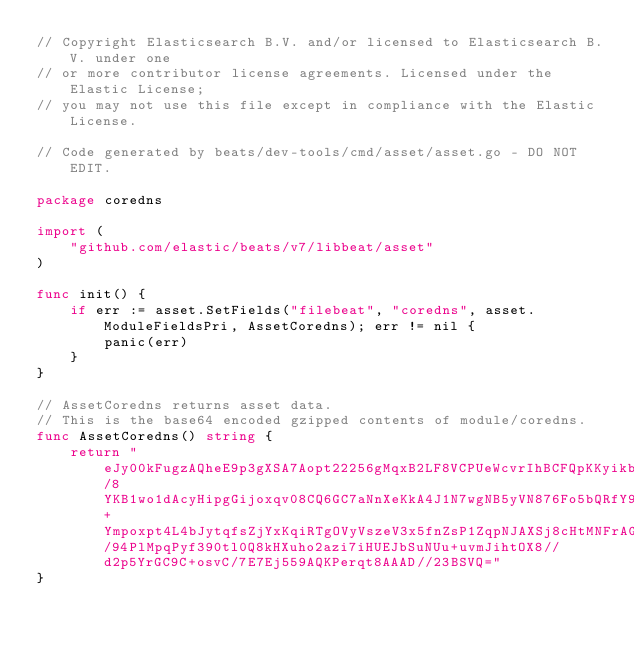<code> <loc_0><loc_0><loc_500><loc_500><_Go_>// Copyright Elasticsearch B.V. and/or licensed to Elasticsearch B.V. under one
// or more contributor license agreements. Licensed under the Elastic License;
// you may not use this file except in compliance with the Elastic License.

// Code generated by beats/dev-tools/cmd/asset/asset.go - DO NOT EDIT.

package coredns

import (
	"github.com/elastic/beats/v7/libbeat/asset"
)

func init() {
	if err := asset.SetFields("filebeat", "coredns", asset.ModuleFieldsPri, AssetCoredns); err != nil {
		panic(err)
	}
}

// AssetCoredns returns asset data.
// This is the base64 encoded gzipped contents of module/coredns.
func AssetCoredns() string {
	return "eJy00kFugzAQheE9p3gXSA7Aopt22256gMqxB2LF8VCPUeWcvrIhBCFQpKKyikb4/8YKB1wo1dAcyHipgGijoxqv08CQ6GC7aNnXeKkA4J1N7wgNB5yVN876Fo5bQRfY9JoMTmmWbCw5I3U5eoBXV5qD+Ympoxpt4L4bJytqfsZjYxKqiRTgOVyVszeV3x5fnZsP1ZqpNJAXSj8cHtMNFrAG3CCeCW8fn4hBeVG6eAviu6eQjmJvtKCsj9RSmKZN3jrWOKVI8nyBXJyvUJx1XDsl8teLTm0MmVUh/94PlMpqPyf390tl0Q8kHXuho2azi7iHUEJbSuNUu+uvmJihtOX8//d2p5YrGC9C+osvC/7E7Ej559AQKPerqt8AAAD//23BSVQ="
}
</code> 